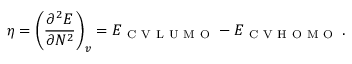<formula> <loc_0><loc_0><loc_500><loc_500>\eta = \left ( \frac { \partial ^ { 2 } E } { \partial N ^ { 2 } } \right ) _ { v } = E _ { C V L U M O } - E _ { C V H O M O } \, .</formula> 